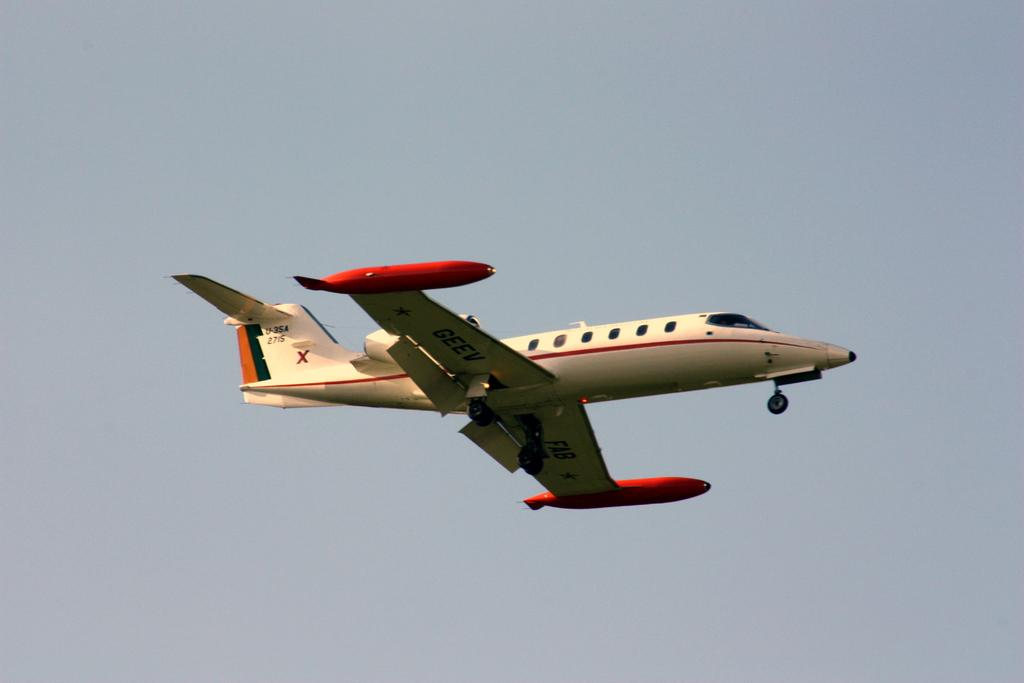Where was the image taken? The image is taken outdoors. What can be seen in the background of the image? There is a sky visible in the background of the image. What is happening in the sky in the middle of the image? An airplane is flying in the sky in the middle of the image. Where is the heart-shaped mailbox located in the image? There is no heart-shaped mailbox present in the image. What type of treatment is being administered to the airplane in the image? There is no treatment being administered to the airplane in the image; it is simply flying in the sky. 